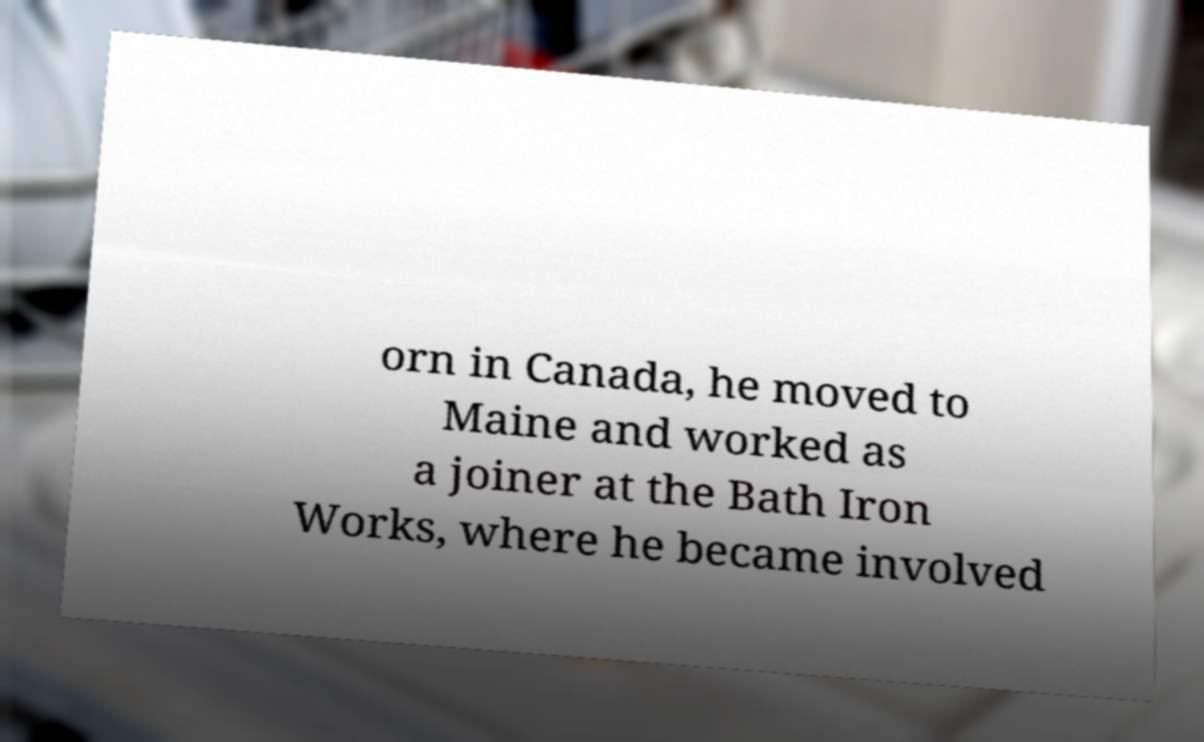Please read and relay the text visible in this image. What does it say? orn in Canada, he moved to Maine and worked as a joiner at the Bath Iron Works, where he became involved 